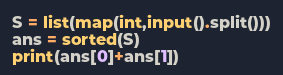<code> <loc_0><loc_0><loc_500><loc_500><_Python_>S = list(map(int,input().split()))
ans = sorted(S)
print(ans[0]+ans[1])</code> 